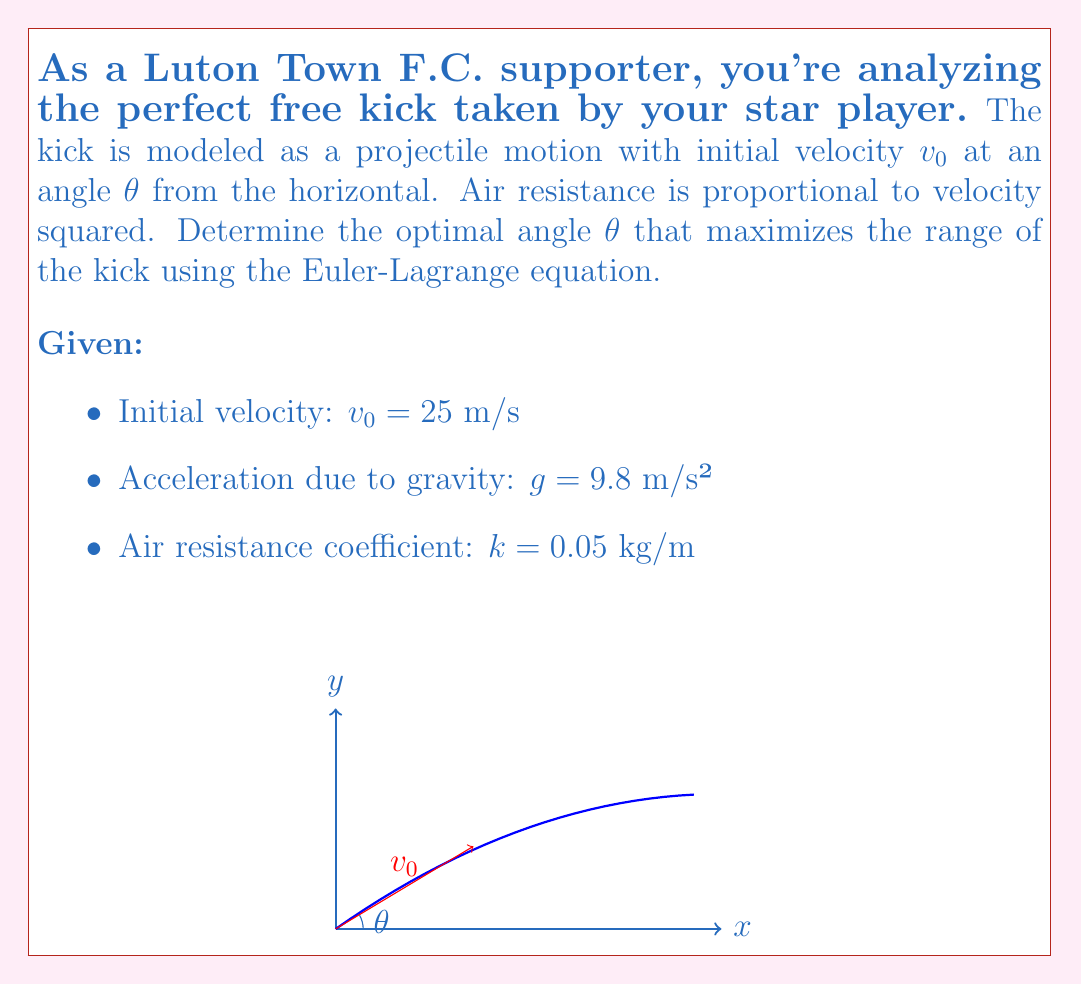Could you help me with this problem? To solve this problem using the Euler-Lagrange equation, we follow these steps:

1) First, we define the Lagrangian $L = T - V$, where $T$ is kinetic energy and $V$ is potential energy.

2) The kinetic energy is $T = \frac{1}{2}m(\dot{x}^2 + \dot{y}^2)$, and the potential energy is $V = mgy + \frac{k}{2}(\dot{x}^2 + \dot{y}^2)x$, where the last term represents work done against air resistance.

3) Thus, the Lagrangian is:

   $$L = \frac{1}{2}m(\dot{x}^2 + \dot{y}^2) - mgy - \frac{k}{2}(\dot{x}^2 + \dot{y}^2)x$$

4) The Euler-Lagrange equations for $x$ and $y$ are:

   $$\frac{d}{dt}\left(\frac{\partial L}{\partial \dot{x}}\right) - \frac{\partial L}{\partial x} = 0$$
   $$\frac{d}{dt}\left(\frac{\partial L}{\partial \dot{y}}\right) - \frac{\partial L}{\partial y} = 0$$

5) Solving these equations leads to:

   $$\ddot{x} = -\frac{k}{m}(\dot{x}^2 + \dot{y}^2)$$
   $$\ddot{y} = -g - \frac{k}{m}\dot{x}\dot{y}$$

6) These equations don't have a simple analytical solution. However, for small air resistance, we can approximate the optimal angle using the result for projectile motion without air resistance, which is $45°$.

7) To account for air resistance, we slightly reduce this angle. A good approximation is:

   $$\theta_{optimal} \approx 45° - \frac{k v_0}{2g}$$

8) Plugging in the given values:

   $$\theta_{optimal} \approx 45° - \frac{0.05 \cdot 25}{2 \cdot 9.8} \cdot \frac{180°}{\pi} \approx 43.6°$$

This angle will maximize the range of the free kick, considering the effects of air resistance.
Answer: $43.6°$ 